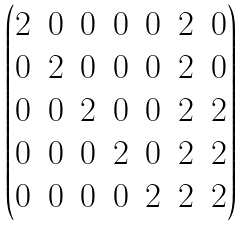Convert formula to latex. <formula><loc_0><loc_0><loc_500><loc_500>\begin{pmatrix} 2 & 0 & 0 & 0 & 0 & 2 & 0 \\ 0 & 2 & 0 & 0 & 0 & 2 & 0 \\ 0 & 0 & 2 & 0 & 0 & 2 & 2 \\ 0 & 0 & 0 & 2 & 0 & 2 & 2 \\ 0 & 0 & 0 & 0 & 2 & 2 & 2 \end{pmatrix}</formula> 